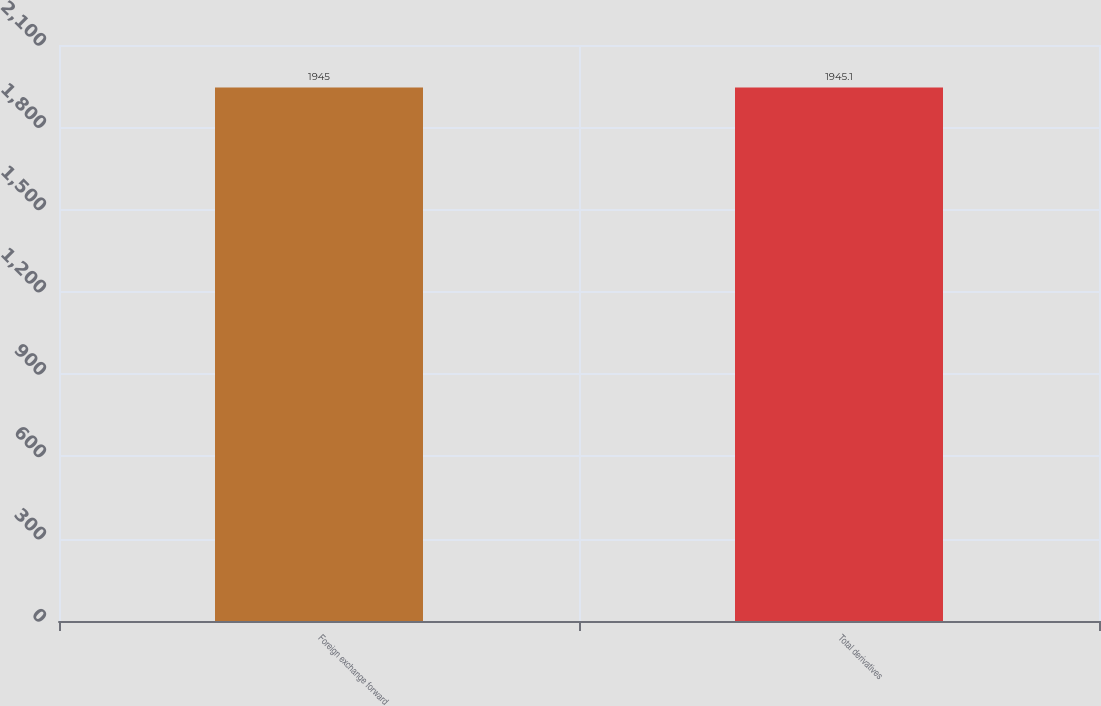<chart> <loc_0><loc_0><loc_500><loc_500><bar_chart><fcel>Foreign exchange forward<fcel>Total derivatives<nl><fcel>1945<fcel>1945.1<nl></chart> 